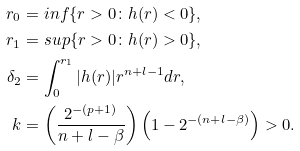<formula> <loc_0><loc_0><loc_500><loc_500>r _ { 0 } & = i n f \{ r > 0 \colon h ( r ) < 0 \} , \\ r _ { 1 } & = s u p \{ r > 0 \colon h ( r ) > 0 \} , \\ \delta _ { 2 } & = \int _ { 0 } ^ { r _ { 1 } } | h ( r ) | r ^ { n + l - 1 } d r , \\ k & = \left ( \frac { 2 ^ { - ( p + 1 ) } } { n + l - \beta } \right ) \left ( 1 - 2 ^ { - ( n + l - \beta ) } \right ) > 0 .</formula> 